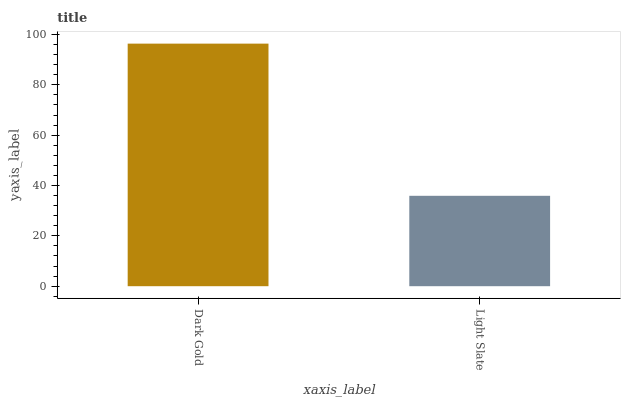Is Light Slate the minimum?
Answer yes or no. Yes. Is Dark Gold the maximum?
Answer yes or no. Yes. Is Light Slate the maximum?
Answer yes or no. No. Is Dark Gold greater than Light Slate?
Answer yes or no. Yes. Is Light Slate less than Dark Gold?
Answer yes or no. Yes. Is Light Slate greater than Dark Gold?
Answer yes or no. No. Is Dark Gold less than Light Slate?
Answer yes or no. No. Is Dark Gold the high median?
Answer yes or no. Yes. Is Light Slate the low median?
Answer yes or no. Yes. Is Light Slate the high median?
Answer yes or no. No. Is Dark Gold the low median?
Answer yes or no. No. 